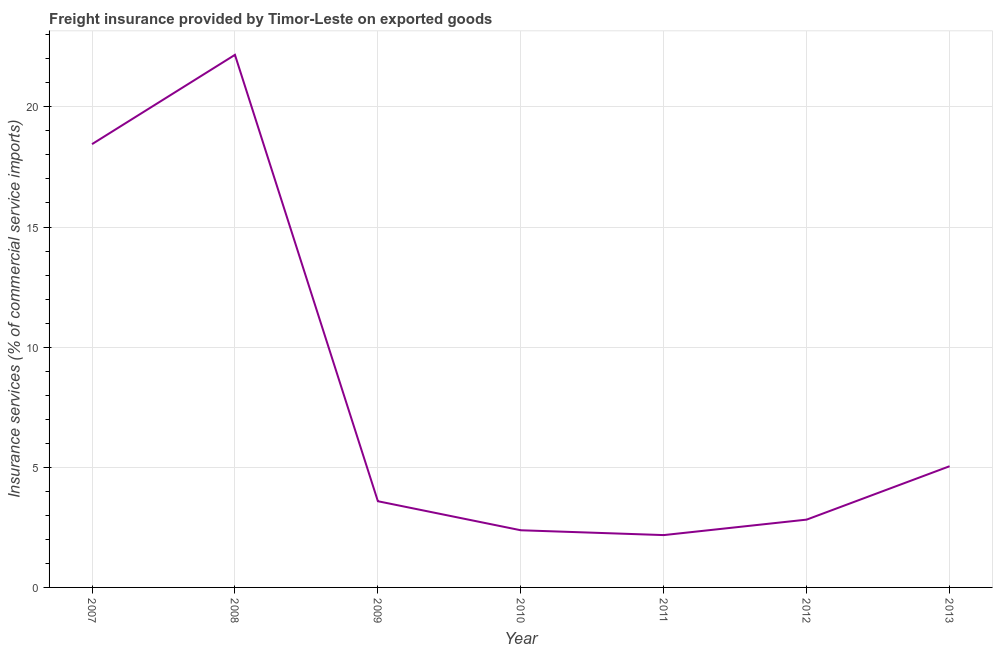What is the freight insurance in 2010?
Give a very brief answer. 2.38. Across all years, what is the maximum freight insurance?
Provide a short and direct response. 22.17. Across all years, what is the minimum freight insurance?
Offer a terse response. 2.18. In which year was the freight insurance maximum?
Give a very brief answer. 2008. In which year was the freight insurance minimum?
Make the answer very short. 2011. What is the sum of the freight insurance?
Provide a short and direct response. 56.63. What is the difference between the freight insurance in 2009 and 2010?
Provide a short and direct response. 1.21. What is the average freight insurance per year?
Offer a very short reply. 8.09. What is the median freight insurance?
Make the answer very short. 3.59. In how many years, is the freight insurance greater than 6 %?
Ensure brevity in your answer.  2. What is the ratio of the freight insurance in 2010 to that in 2012?
Keep it short and to the point. 0.84. What is the difference between the highest and the second highest freight insurance?
Give a very brief answer. 3.72. Is the sum of the freight insurance in 2010 and 2013 greater than the maximum freight insurance across all years?
Offer a terse response. No. What is the difference between the highest and the lowest freight insurance?
Provide a succinct answer. 19.99. In how many years, is the freight insurance greater than the average freight insurance taken over all years?
Give a very brief answer. 2. Does the freight insurance monotonically increase over the years?
Provide a succinct answer. No. Are the values on the major ticks of Y-axis written in scientific E-notation?
Provide a succinct answer. No. Does the graph contain any zero values?
Your answer should be very brief. No. Does the graph contain grids?
Offer a very short reply. Yes. What is the title of the graph?
Make the answer very short. Freight insurance provided by Timor-Leste on exported goods . What is the label or title of the Y-axis?
Keep it short and to the point. Insurance services (% of commercial service imports). What is the Insurance services (% of commercial service imports) of 2007?
Keep it short and to the point. 18.45. What is the Insurance services (% of commercial service imports) of 2008?
Give a very brief answer. 22.17. What is the Insurance services (% of commercial service imports) of 2009?
Keep it short and to the point. 3.59. What is the Insurance services (% of commercial service imports) in 2010?
Make the answer very short. 2.38. What is the Insurance services (% of commercial service imports) in 2011?
Ensure brevity in your answer.  2.18. What is the Insurance services (% of commercial service imports) of 2012?
Give a very brief answer. 2.82. What is the Insurance services (% of commercial service imports) in 2013?
Provide a succinct answer. 5.04. What is the difference between the Insurance services (% of commercial service imports) in 2007 and 2008?
Keep it short and to the point. -3.72. What is the difference between the Insurance services (% of commercial service imports) in 2007 and 2009?
Provide a short and direct response. 14.86. What is the difference between the Insurance services (% of commercial service imports) in 2007 and 2010?
Offer a terse response. 16.07. What is the difference between the Insurance services (% of commercial service imports) in 2007 and 2011?
Ensure brevity in your answer.  16.27. What is the difference between the Insurance services (% of commercial service imports) in 2007 and 2012?
Give a very brief answer. 15.63. What is the difference between the Insurance services (% of commercial service imports) in 2007 and 2013?
Your answer should be compact. 13.4. What is the difference between the Insurance services (% of commercial service imports) in 2008 and 2009?
Make the answer very short. 18.58. What is the difference between the Insurance services (% of commercial service imports) in 2008 and 2010?
Your answer should be compact. 19.79. What is the difference between the Insurance services (% of commercial service imports) in 2008 and 2011?
Your answer should be compact. 19.99. What is the difference between the Insurance services (% of commercial service imports) in 2008 and 2012?
Give a very brief answer. 19.34. What is the difference between the Insurance services (% of commercial service imports) in 2008 and 2013?
Provide a short and direct response. 17.12. What is the difference between the Insurance services (% of commercial service imports) in 2009 and 2010?
Offer a terse response. 1.21. What is the difference between the Insurance services (% of commercial service imports) in 2009 and 2011?
Provide a succinct answer. 1.41. What is the difference between the Insurance services (% of commercial service imports) in 2009 and 2012?
Offer a very short reply. 0.77. What is the difference between the Insurance services (% of commercial service imports) in 2009 and 2013?
Offer a terse response. -1.46. What is the difference between the Insurance services (% of commercial service imports) in 2010 and 2011?
Ensure brevity in your answer.  0.2. What is the difference between the Insurance services (% of commercial service imports) in 2010 and 2012?
Make the answer very short. -0.44. What is the difference between the Insurance services (% of commercial service imports) in 2010 and 2013?
Ensure brevity in your answer.  -2.67. What is the difference between the Insurance services (% of commercial service imports) in 2011 and 2012?
Provide a short and direct response. -0.64. What is the difference between the Insurance services (% of commercial service imports) in 2011 and 2013?
Offer a terse response. -2.87. What is the difference between the Insurance services (% of commercial service imports) in 2012 and 2013?
Keep it short and to the point. -2.22. What is the ratio of the Insurance services (% of commercial service imports) in 2007 to that in 2008?
Your response must be concise. 0.83. What is the ratio of the Insurance services (% of commercial service imports) in 2007 to that in 2009?
Make the answer very short. 5.14. What is the ratio of the Insurance services (% of commercial service imports) in 2007 to that in 2010?
Provide a succinct answer. 7.75. What is the ratio of the Insurance services (% of commercial service imports) in 2007 to that in 2011?
Make the answer very short. 8.47. What is the ratio of the Insurance services (% of commercial service imports) in 2007 to that in 2012?
Provide a short and direct response. 6.54. What is the ratio of the Insurance services (% of commercial service imports) in 2007 to that in 2013?
Offer a terse response. 3.66. What is the ratio of the Insurance services (% of commercial service imports) in 2008 to that in 2009?
Provide a short and direct response. 6.18. What is the ratio of the Insurance services (% of commercial service imports) in 2008 to that in 2010?
Give a very brief answer. 9.32. What is the ratio of the Insurance services (% of commercial service imports) in 2008 to that in 2011?
Your response must be concise. 10.18. What is the ratio of the Insurance services (% of commercial service imports) in 2008 to that in 2012?
Ensure brevity in your answer.  7.85. What is the ratio of the Insurance services (% of commercial service imports) in 2008 to that in 2013?
Provide a succinct answer. 4.39. What is the ratio of the Insurance services (% of commercial service imports) in 2009 to that in 2010?
Your response must be concise. 1.51. What is the ratio of the Insurance services (% of commercial service imports) in 2009 to that in 2011?
Offer a terse response. 1.65. What is the ratio of the Insurance services (% of commercial service imports) in 2009 to that in 2012?
Your answer should be compact. 1.27. What is the ratio of the Insurance services (% of commercial service imports) in 2009 to that in 2013?
Offer a very short reply. 0.71. What is the ratio of the Insurance services (% of commercial service imports) in 2010 to that in 2011?
Your answer should be compact. 1.09. What is the ratio of the Insurance services (% of commercial service imports) in 2010 to that in 2012?
Ensure brevity in your answer.  0.84. What is the ratio of the Insurance services (% of commercial service imports) in 2010 to that in 2013?
Ensure brevity in your answer.  0.47. What is the ratio of the Insurance services (% of commercial service imports) in 2011 to that in 2012?
Your response must be concise. 0.77. What is the ratio of the Insurance services (% of commercial service imports) in 2011 to that in 2013?
Your answer should be compact. 0.43. What is the ratio of the Insurance services (% of commercial service imports) in 2012 to that in 2013?
Give a very brief answer. 0.56. 